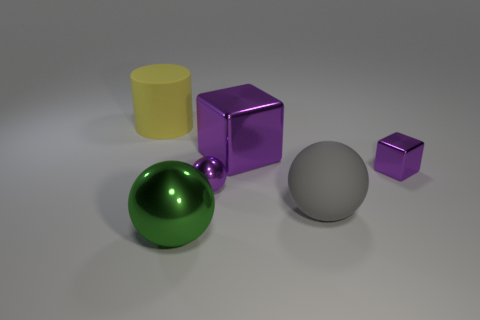Is there a large gray rubber thing that has the same shape as the large yellow thing? no 